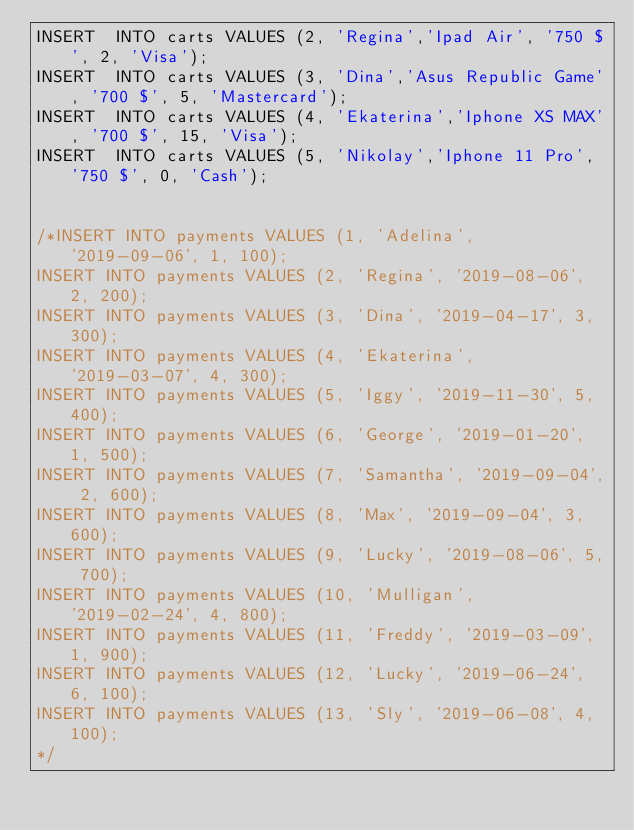Convert code to text. <code><loc_0><loc_0><loc_500><loc_500><_SQL_>INSERT  INTO carts VALUES (2, 'Regina','Ipad Air', '750 $', 2, 'Visa');
INSERT  INTO carts VALUES (3, 'Dina','Asus Republic Game', '700 $', 5, 'Mastercard');
INSERT  INTO carts VALUES (4, 'Ekaterina','Iphone XS MAX', '700 $', 15, 'Visa');
INSERT  INTO carts VALUES (5, 'Nikolay','Iphone 11 Pro', '750 $', 0, 'Cash');


/*INSERT INTO payments VALUES (1, 'Adelina', '2019-09-06', 1, 100);
INSERT INTO payments VALUES (2, 'Regina', '2019-08-06', 2, 200);
INSERT INTO payments VALUES (3, 'Dina', '2019-04-17', 3, 300);
INSERT INTO payments VALUES (4, 'Ekaterina', '2019-03-07', 4, 300);
INSERT INTO payments VALUES (5, 'Iggy', '2019-11-30', 5, 400);
INSERT INTO payments VALUES (6, 'George', '2019-01-20', 1, 500);
INSERT INTO payments VALUES (7, 'Samantha', '2019-09-04', 2, 600);
INSERT INTO payments VALUES (8, 'Max', '2019-09-04', 3, 600);
INSERT INTO payments VALUES (9, 'Lucky', '2019-08-06', 5, 700);
INSERT INTO payments VALUES (10, 'Mulligan', '2019-02-24', 4, 800);
INSERT INTO payments VALUES (11, 'Freddy', '2019-03-09', 1, 900);
INSERT INTO payments VALUES (12, 'Lucky', '2019-06-24', 6, 100);
INSERT INTO payments VALUES (13, 'Sly', '2019-06-08', 4, 100);
*/
</code> 